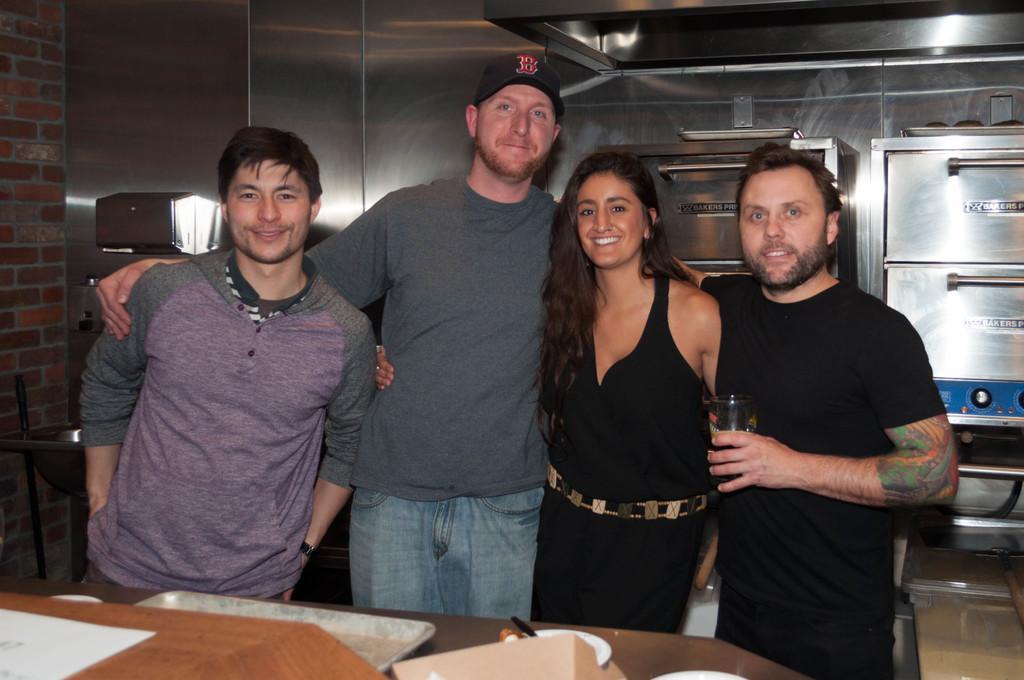Describe this image in one or two sentences. In the picture I can see four persons standing and one them holding the glass. I can see some other objects on the table. 